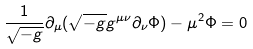Convert formula to latex. <formula><loc_0><loc_0><loc_500><loc_500>\frac { 1 } { \sqrt { - g } } \partial _ { \mu } ( \sqrt { - g } g ^ { \mu \nu } \partial _ { \nu } \Phi ) - \mu ^ { 2 } \Phi = 0</formula> 